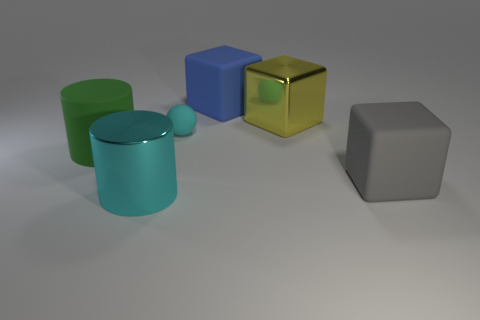Does the big thing that is behind the big yellow metal block have the same shape as the gray matte thing?
Keep it short and to the point. Yes. What shape is the thing in front of the block in front of the matte sphere?
Your answer should be very brief. Cylinder. Are there any other things that are the same shape as the small cyan matte object?
Offer a terse response. No. What color is the other metal object that is the same shape as the blue thing?
Provide a succinct answer. Yellow. Do the big metal cylinder and the rubber ball that is to the right of the green matte thing have the same color?
Ensure brevity in your answer.  Yes. There is a matte thing that is behind the large matte cylinder and right of the small rubber sphere; what is its shape?
Offer a very short reply. Cube. Are there fewer small blue shiny cylinders than shiny objects?
Your answer should be very brief. Yes. Are any tiny red metallic cylinders visible?
Give a very brief answer. No. How many other objects are there of the same size as the cyan matte ball?
Offer a very short reply. 0. Do the large cyan thing and the block that is in front of the small cyan object have the same material?
Keep it short and to the point. No. 